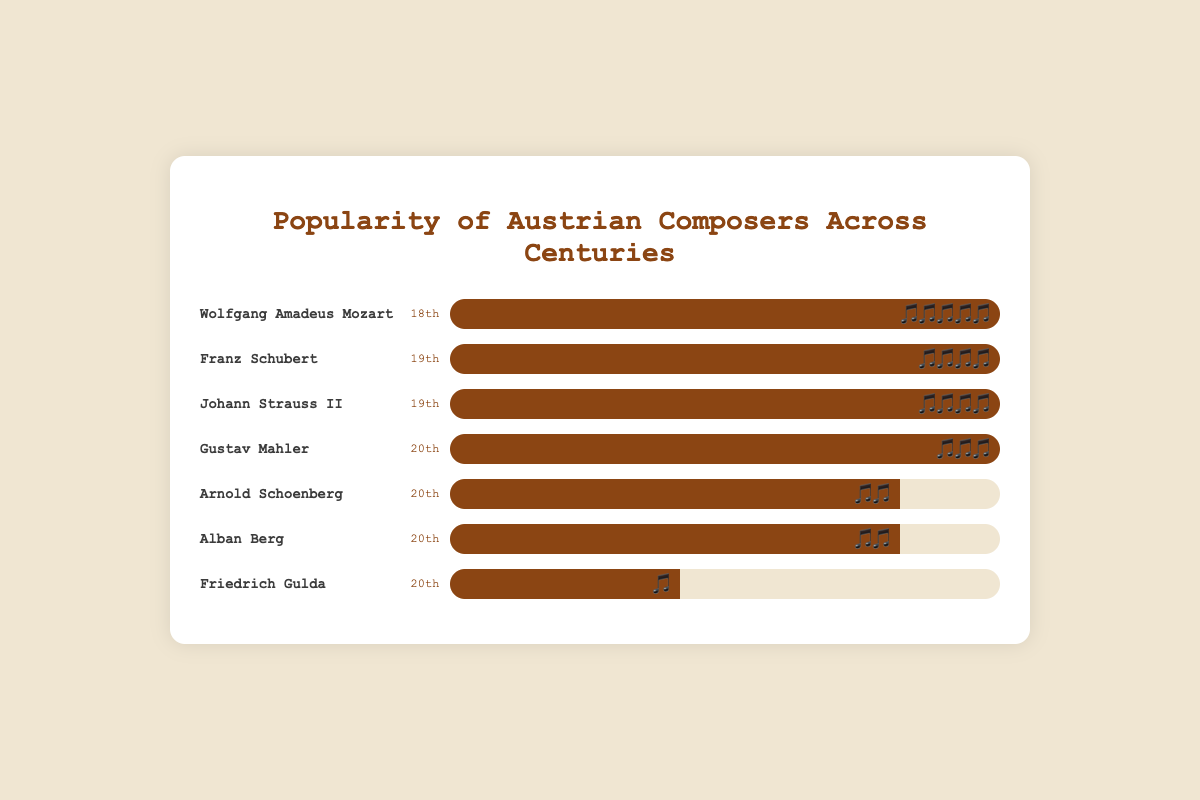Who has the highest popularity score among the composers? Wolfgang Amadeus Mozart has the highest popularity with 5 music notes 🎵🎵🎵🎵🎵, which is more than any other composer.
Answer: Wolfgang Amadeus Mozart Which century has the most composers listed in the chart? The chart shows 1 composer from the 18th century, 2 from the 19th century, and 4 from the 20th century. Thus, the 20th century has the most composers.
Answer: 20th century How many composers have a popularity score of 4 music notes? The chart indicates that Franz Schubert and Johann Strauss II, both from the 19th century, have a popularity score of 4 music notes 🎵🎵🎵🎵. There are therefore 2 composers with this score.
Answer: 2 What is the combined popularity score of all composers in the 20th century? Gustav Mahler has 3 notes, Arnold Schoenberg has 2 notes, Alban Berg has 2 notes, and Friedrich Gulda has 1 note. Summing these up, 3 + 2 + 2 + 1 = 8 notes.
Answer: 8 Compare the popularity scores of Johann Strauss II and Arnold Schoenberg. Who is more popular? Johann Strauss II has a popularity score of 4 music notes 🎵🎵🎵🎵, whereas Arnold Schoenberg has a score of 2 music notes 🎵🎵. Johann Strauss II is more popular.
Answer: Johann Strauss II Which composer has the least popularity in the 20th century? Friedrich Gulda has the least popularity in the 20th century with 1 music note 🎵, which is fewer than Mahler (3), Schoenberg (2), and Berg (2).
Answer: Friedrich Gulda How does the popularity of Franz Schubert compare to that of Gustav Mahler? Franz Schubert has a popularity of 4 music notes 🎵🎵🎵🎵, while Gustav Mahler has 3 music notes 🎵🎵🎵. Franz Schubert is more popular.
Answer: Franz Schubert What is the average popularity score of the composers in the 19th century? Franz Schubert and Johann Strauss II both have 4 music notes 🎵🎵🎵🎵. Adding them gives 4 + 4 = 8 notes. Dividing by 2 composers gives an average of 8/2 = 4 music notes.
Answer: 4 From the chart, how many composers have a higher popularity score than Arnold Schoenberg? Composers with more than 2 music notes (Arnold Schoenberg's score) are Mozart with 5 🎵🎵🎵🎵🎵, Schubert with 4 🎵🎵🎵🎵, Strauss II with 4 🎵🎵🎵🎵, and Mahler with 3 🎵🎵🎵. There are 4 such composers.
Answer: 4 Which composers are from the 19th century? The composers from the 19th century in the chart are Franz Schubert and Johann Strauss II.
Answer: Franz Schubert and Johann Strauss II 